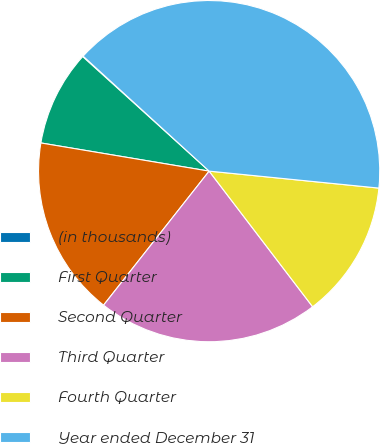Convert chart to OTSL. <chart><loc_0><loc_0><loc_500><loc_500><pie_chart><fcel>(in thousands)<fcel>First Quarter<fcel>Second Quarter<fcel>Third Quarter<fcel>Fourth Quarter<fcel>Year ended December 31<nl><fcel>0.06%<fcel>9.07%<fcel>17.02%<fcel>20.99%<fcel>13.04%<fcel>39.81%<nl></chart> 